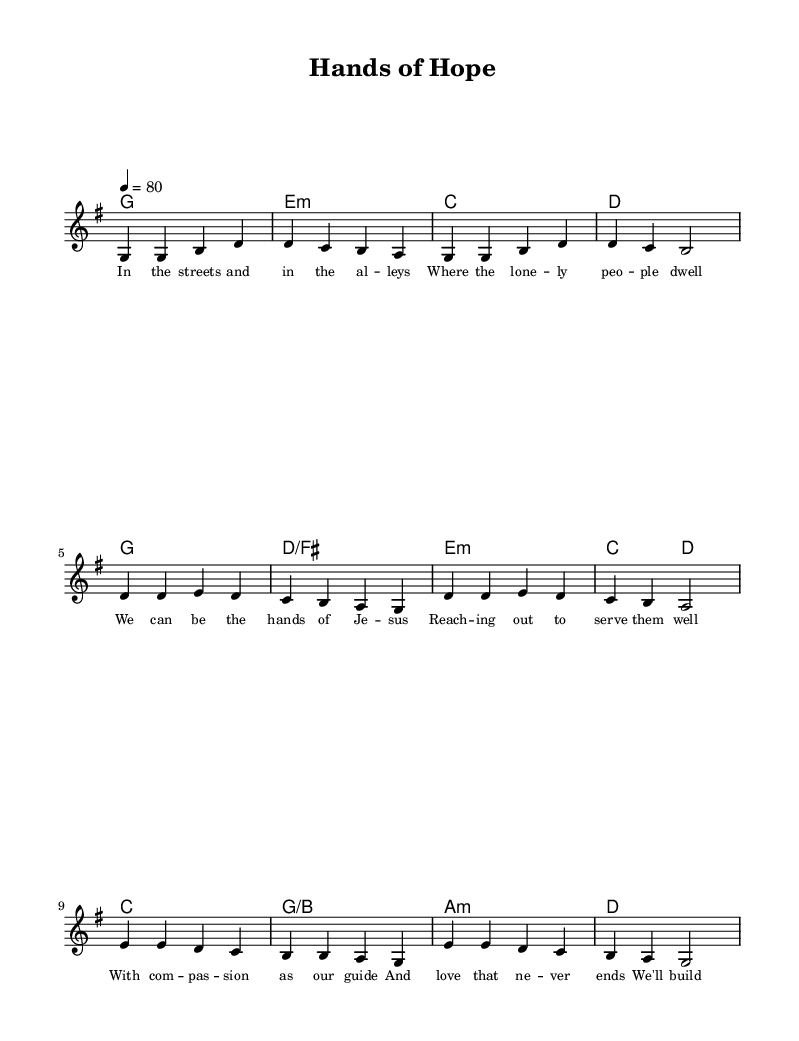What is the key signature of this music? The key signature is G major, which has one sharp (F#). This can be identified at the beginning of the staff where the key signature is indicated.
Answer: G major What is the time signature of this music? The time signature is 4/4, which is indicated at the beginning of the score. This means there are four beats per measure and the quarter note gets one beat.
Answer: 4/4 What is the tempo marking for this piece? The tempo marking is quarter note equals 80, indicated in the score. It tells the performer to play at a moderate speed of 80 beats per minute.
Answer: 80 How many sections are there in the song? The song has three sections: the Verse, Chorus, and Bridge. This is evident from the layout of the lyrics and the structure indicated in the score.
Answer: Three Which section contains the line "We'll build a stronger community"? This line appears in the Chorus, where themes of kindness and community service are emphasized. The Chorus is distinct in structure and often repeats in songs.
Answer: Chorus What is the primary theme of the lyrics in this song? The primary theme is compassion and community service, highlighted throughout the lyrics that focus on helping others and sharing blessings.
Answer: Compassion and community service Which chord is played during the Bridge section? The chords played during the Bridge are C major, G major with B in the bass, A minor, and D major. These chords accompany the melody and lyrics that emphasize action and service.
Answer: C, G/B, A minor, D 